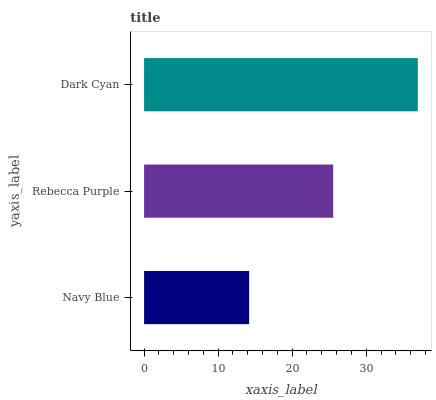Is Navy Blue the minimum?
Answer yes or no. Yes. Is Dark Cyan the maximum?
Answer yes or no. Yes. Is Rebecca Purple the minimum?
Answer yes or no. No. Is Rebecca Purple the maximum?
Answer yes or no. No. Is Rebecca Purple greater than Navy Blue?
Answer yes or no. Yes. Is Navy Blue less than Rebecca Purple?
Answer yes or no. Yes. Is Navy Blue greater than Rebecca Purple?
Answer yes or no. No. Is Rebecca Purple less than Navy Blue?
Answer yes or no. No. Is Rebecca Purple the high median?
Answer yes or no. Yes. Is Rebecca Purple the low median?
Answer yes or no. Yes. Is Dark Cyan the high median?
Answer yes or no. No. Is Navy Blue the low median?
Answer yes or no. No. 